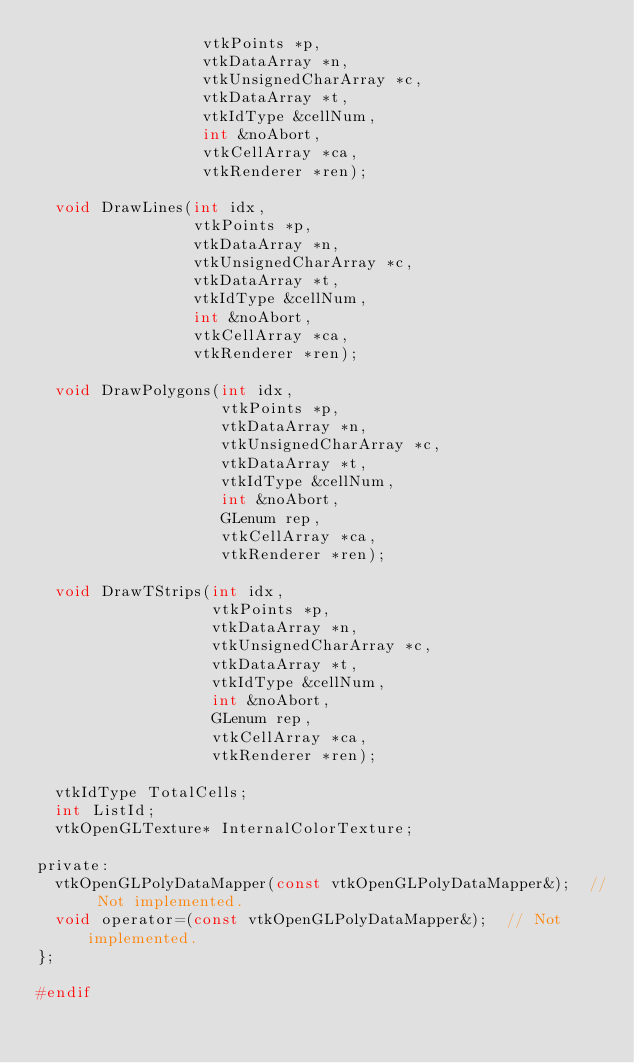Convert code to text. <code><loc_0><loc_0><loc_500><loc_500><_C_>                  vtkPoints *p, 
                  vtkDataArray *n,
                  vtkUnsignedCharArray *c,
                  vtkDataArray *t,
                  vtkIdType &cellNum,
                  int &noAbort,
                  vtkCellArray *ca,
                  vtkRenderer *ren);
  
  void DrawLines(int idx,
                 vtkPoints *p, 
                 vtkDataArray *n,
                 vtkUnsignedCharArray *c,
                 vtkDataArray *t,
                 vtkIdType &cellNum,
                 int &noAbort,
                 vtkCellArray *ca,
                 vtkRenderer *ren);

  void DrawPolygons(int idx,
                    vtkPoints *p, 
                    vtkDataArray *n,
                    vtkUnsignedCharArray *c,
                    vtkDataArray *t,
                    vtkIdType &cellNum,
                    int &noAbort,
                    GLenum rep,
                    vtkCellArray *ca,
                    vtkRenderer *ren);

  void DrawTStrips(int idx,
                   vtkPoints *p, 
                   vtkDataArray *n,
                   vtkUnsignedCharArray *c,
                   vtkDataArray *t,
                   vtkIdType &cellNum,
                   int &noAbort,
                   GLenum rep,
                   vtkCellArray *ca,
                   vtkRenderer *ren);
    
  vtkIdType TotalCells;
  int ListId;
  vtkOpenGLTexture* InternalColorTexture;

private:
  vtkOpenGLPolyDataMapper(const vtkOpenGLPolyDataMapper&);  // Not implemented.
  void operator=(const vtkOpenGLPolyDataMapper&);  // Not implemented.
};

#endif
</code> 